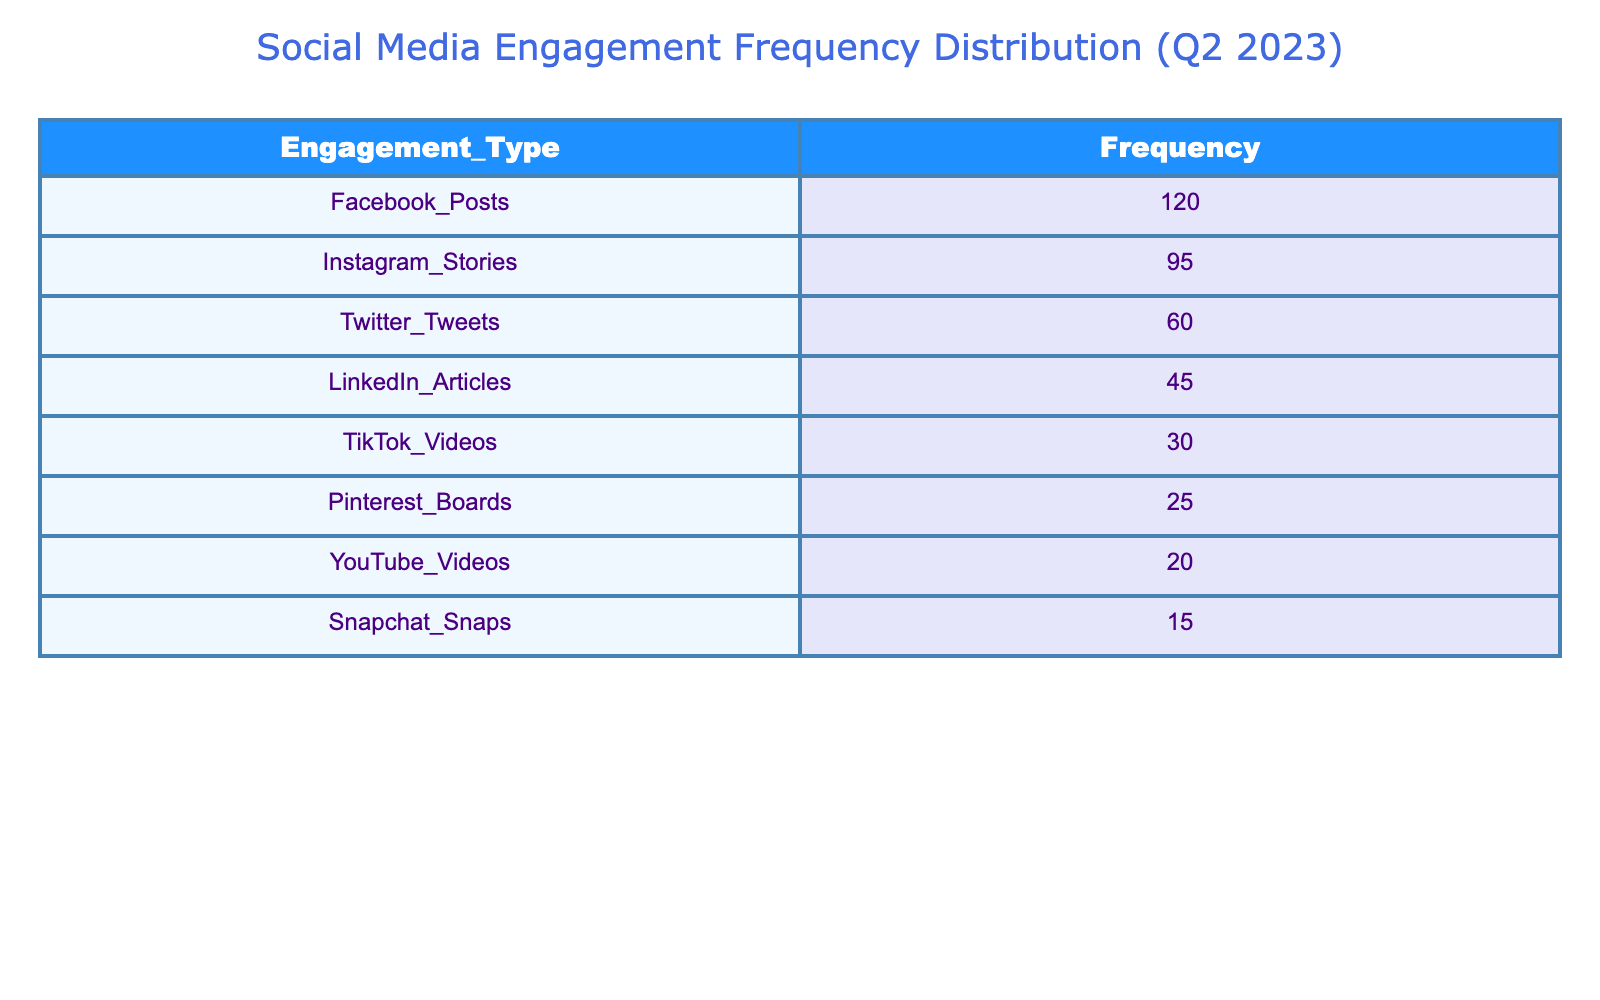What is the frequency of Facebook Posts? The table shows that the frequency of Facebook Posts is explicitly listed under the Engagement_Type column, with a corresponding value in the Frequency column.
Answer: 120 Which social media platform had the lowest engagement frequency? By examining the Frequency column, we see the highest value appears for Facebook, and as we move down the list, the values decrease. The lowest frequency is for Snapchat Snaps at 15.
Answer: 15 What is the difference in frequency between Instagram Stories and Twitter Tweets? We identify Instagram Stories with a frequency of 95 and Twitter Tweets with a frequency of 60. Calculating the difference gives us 95 - 60 = 35.
Answer: 35 True or False: YouTube Videos had a higher engagement frequency than TikTok Videos. Looking at their respective frequencies, YouTube Videos had a frequency of 20 and TikTok Videos had a higher frequency of 30. Therefore, the statement is false.
Answer: False What is the total frequency of posts for all platforms combined? To find the total frequency, we sum up all the values from the Frequency column: 120 + 95 + 60 + 45 + 30 + 25 + 20 + 15 = 400.
Answer: 400 True or False: LinkedIn Articles had the highest engagement frequency. Checking the table, the frequency for LinkedIn Articles is 45, which is lower than the frequency for Facebook Posts (120). Thus, this statement is false.
Answer: False What is the average engagement frequency across all platforms? To calculate the average, we first find the total frequency, which is 400, and then divide by the number of platforms, which is 8. Therefore, 400 / 8 = 50.
Answer: 50 Which two platforms together had a higher engagement frequency than Facebook Posts? Facebook Posts has a frequency of 120. Checking combinations, Instagram Stories (95) and Twitter Tweets (60) total 155 which is greater than 120. Hence, these two platforms have higher engagement than Facebook.
Answer: Instagram Stories and Twitter Tweets What is the median engagement frequency of the listed platforms? To find the median, we first order the frequencies: 15, 20, 25, 30, 45, 60, 95, 120. Since there are 8 values, the median is the average of the 4th and 5th values, (30 + 45) / 2 = 37.5.
Answer: 37.5 